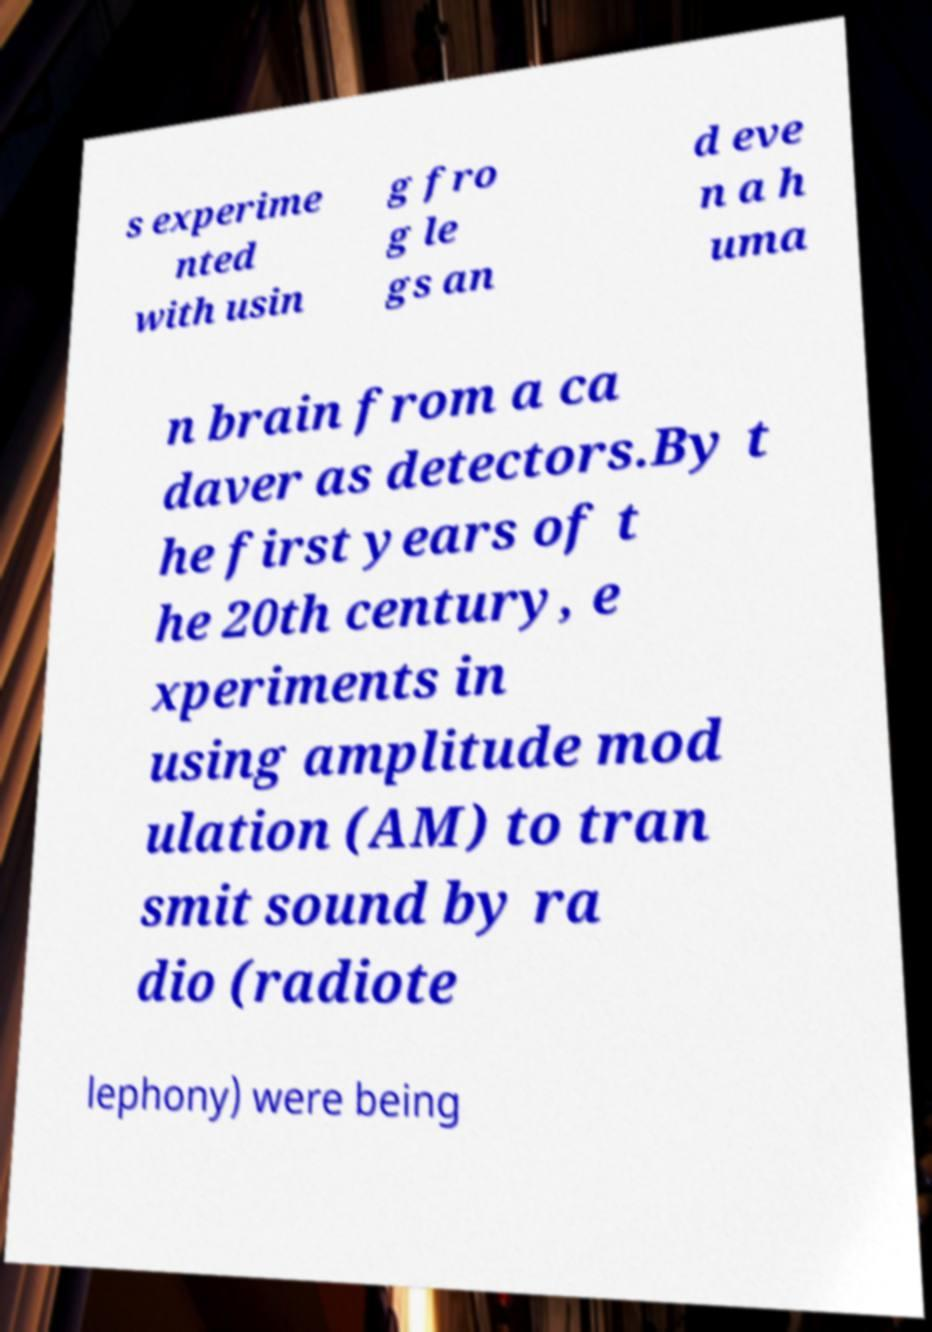Can you read and provide the text displayed in the image?This photo seems to have some interesting text. Can you extract and type it out for me? s experime nted with usin g fro g le gs an d eve n a h uma n brain from a ca daver as detectors.By t he first years of t he 20th century, e xperiments in using amplitude mod ulation (AM) to tran smit sound by ra dio (radiote lephony) were being 